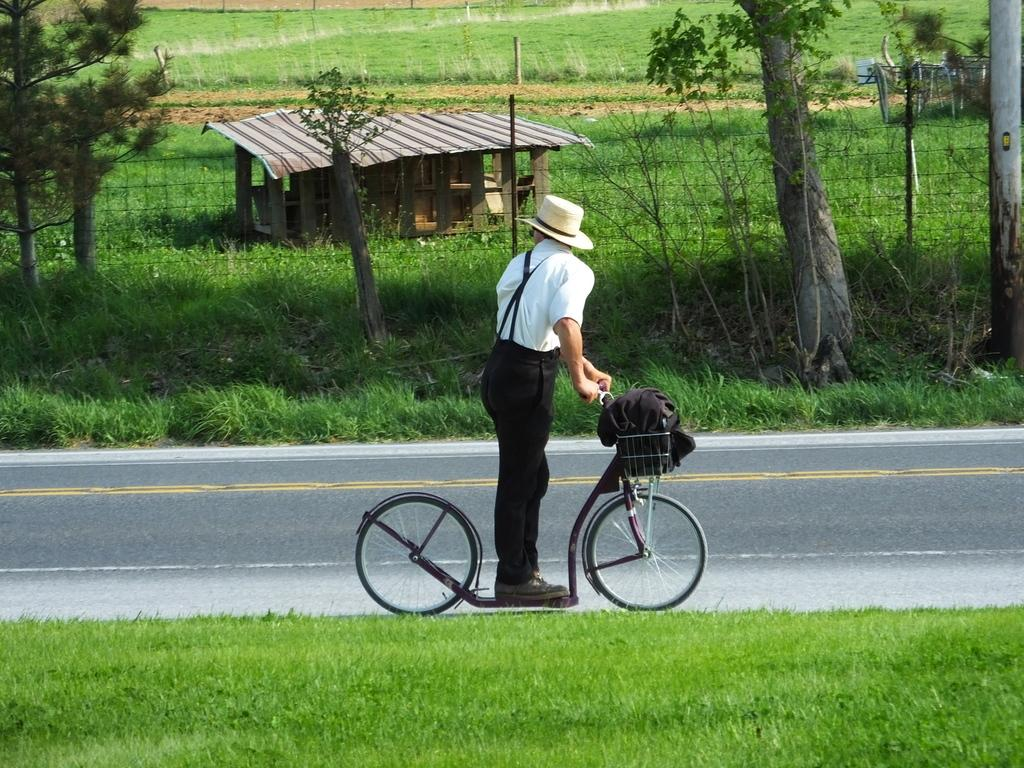What is the man doing in the image? The man is standing on a cycle in the image. Where is the cycle located? The cycle is on the road in the image. What can be seen on both sides of the road? There is grass on both sides of the road in the image. What is visible in the background of the image? There are trees, grass, a shed, a field, and a plant in the background of the image. What type of clover is growing on the field in the background? There is no clover visible in the image; only grass, trees, a shed, and a plant can be seen in the background. What kind of spark can be seen coming from the cycle in the image? There is no spark present in the image; the cycle is stationary with the man standing on it. 